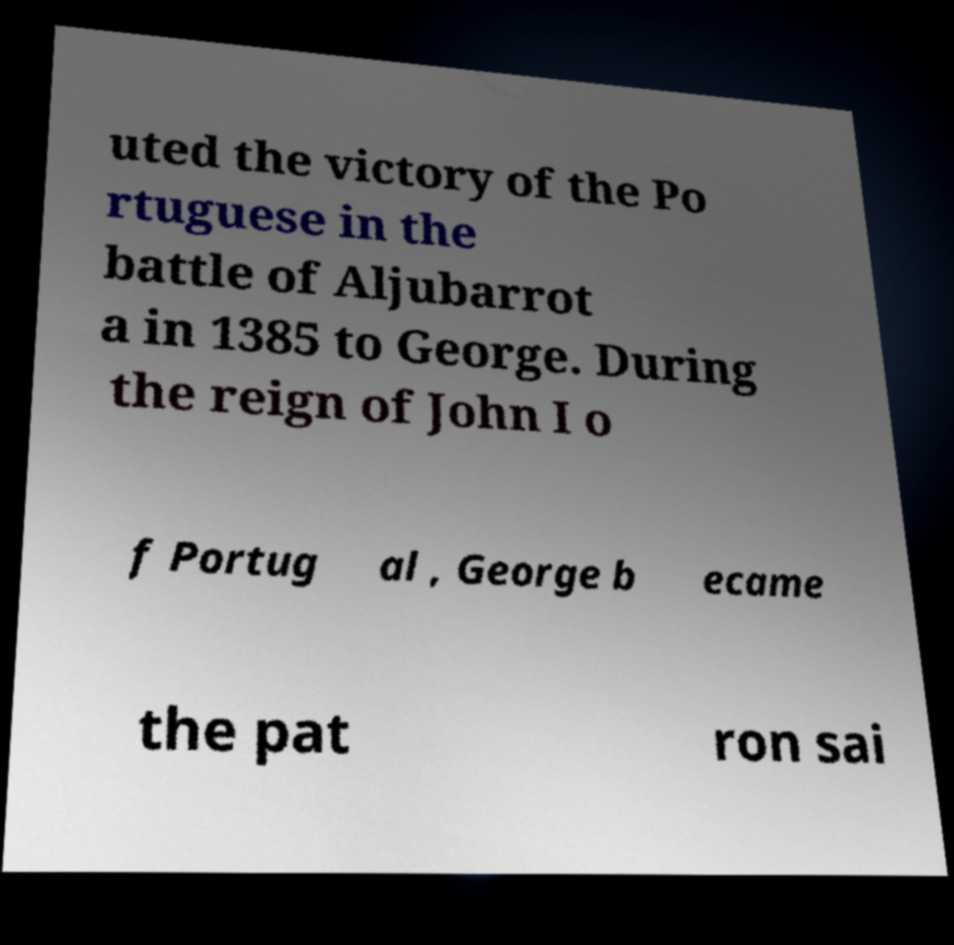Could you extract and type out the text from this image? uted the victory of the Po rtuguese in the battle of Aljubarrot a in 1385 to George. During the reign of John I o f Portug al , George b ecame the pat ron sai 